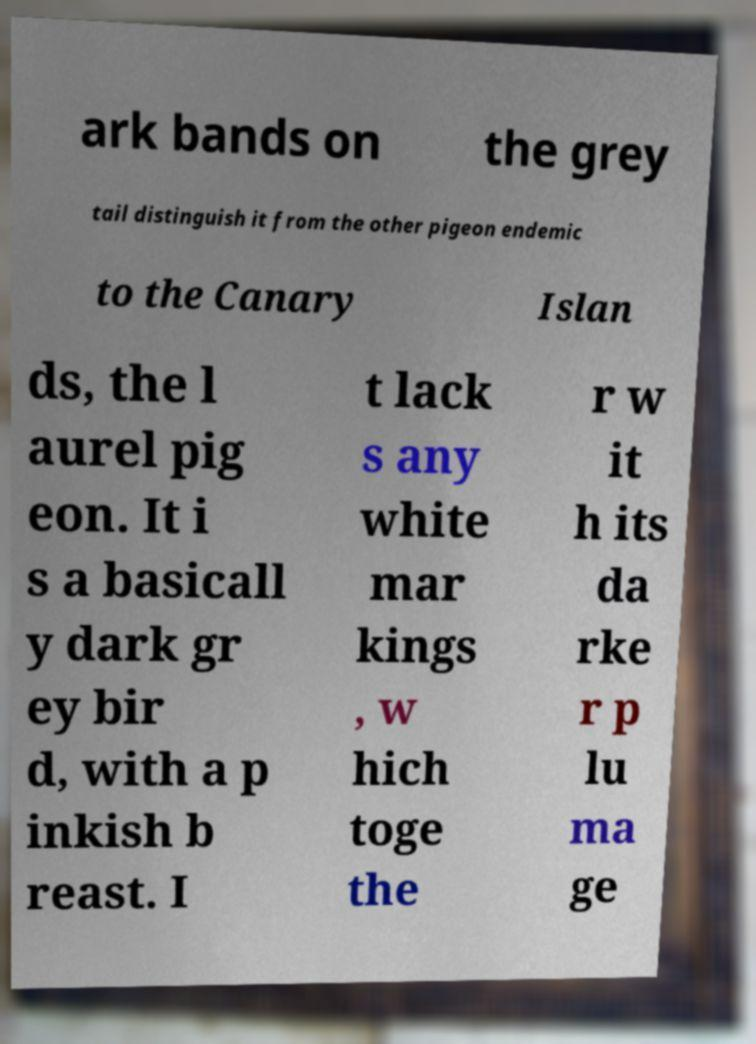Please read and relay the text visible in this image. What does it say? ark bands on the grey tail distinguish it from the other pigeon endemic to the Canary Islan ds, the l aurel pig eon. It i s a basicall y dark gr ey bir d, with a p inkish b reast. I t lack s any white mar kings , w hich toge the r w it h its da rke r p lu ma ge 